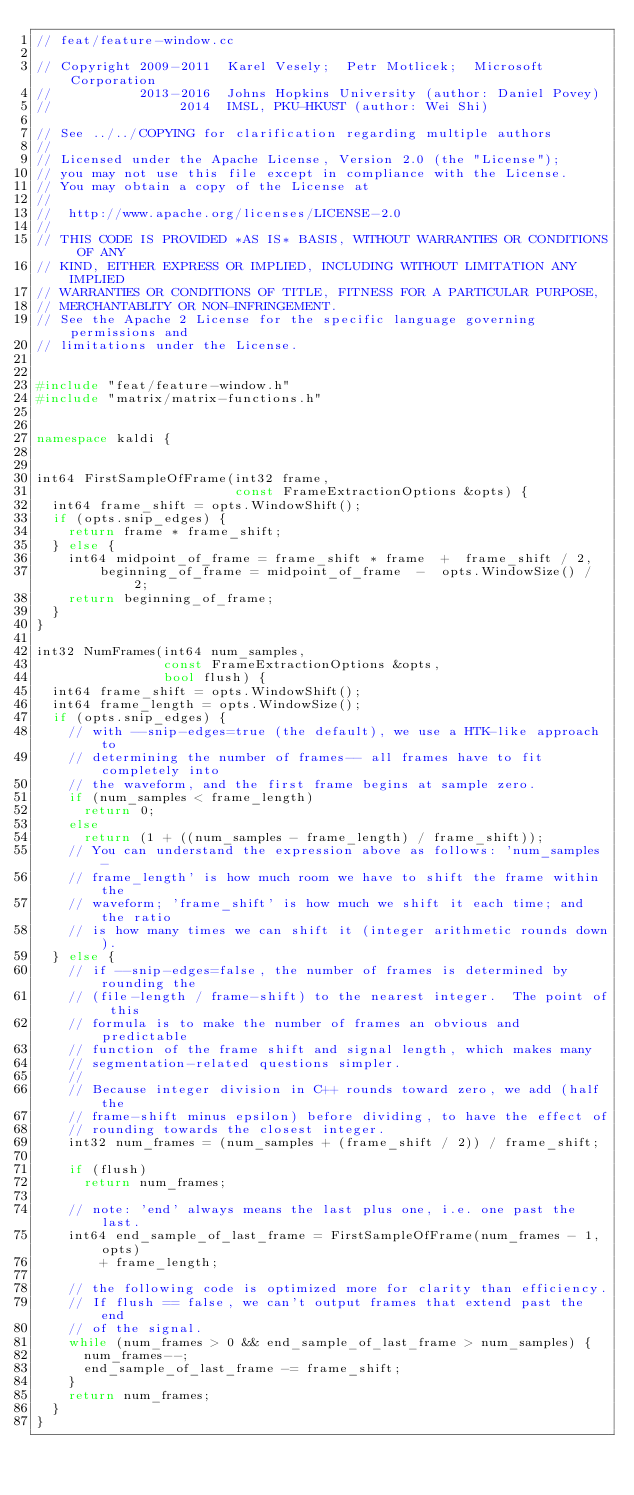Convert code to text. <code><loc_0><loc_0><loc_500><loc_500><_C++_>// feat/feature-window.cc

// Copyright 2009-2011  Karel Vesely;  Petr Motlicek;  Microsoft Corporation
//           2013-2016  Johns Hopkins University (author: Daniel Povey)
//                2014  IMSL, PKU-HKUST (author: Wei Shi)

// See ../../COPYING for clarification regarding multiple authors
//
// Licensed under the Apache License, Version 2.0 (the "License");
// you may not use this file except in compliance with the License.
// You may obtain a copy of the License at
//
//  http://www.apache.org/licenses/LICENSE-2.0
//
// THIS CODE IS PROVIDED *AS IS* BASIS, WITHOUT WARRANTIES OR CONDITIONS OF ANY
// KIND, EITHER EXPRESS OR IMPLIED, INCLUDING WITHOUT LIMITATION ANY IMPLIED
// WARRANTIES OR CONDITIONS OF TITLE, FITNESS FOR A PARTICULAR PURPOSE,
// MERCHANTABLITY OR NON-INFRINGEMENT.
// See the Apache 2 License for the specific language governing permissions and
// limitations under the License.


#include "feat/feature-window.h"
#include "matrix/matrix-functions.h"


namespace kaldi {


int64 FirstSampleOfFrame(int32 frame,
                         const FrameExtractionOptions &opts) {
  int64 frame_shift = opts.WindowShift();
  if (opts.snip_edges) {
    return frame * frame_shift;
  } else {
    int64 midpoint_of_frame = frame_shift * frame  +  frame_shift / 2,
        beginning_of_frame = midpoint_of_frame  -  opts.WindowSize() / 2;
    return beginning_of_frame;
  }
}

int32 NumFrames(int64 num_samples,
                const FrameExtractionOptions &opts,
                bool flush) {
  int64 frame_shift = opts.WindowShift();
  int64 frame_length = opts.WindowSize();
  if (opts.snip_edges) {
    // with --snip-edges=true (the default), we use a HTK-like approach to
    // determining the number of frames-- all frames have to fit completely into
    // the waveform, and the first frame begins at sample zero.
    if (num_samples < frame_length)
      return 0;
    else
      return (1 + ((num_samples - frame_length) / frame_shift));
    // You can understand the expression above as follows: 'num_samples -
    // frame_length' is how much room we have to shift the frame within the
    // waveform; 'frame_shift' is how much we shift it each time; and the ratio
    // is how many times we can shift it (integer arithmetic rounds down).
  } else {
    // if --snip-edges=false, the number of frames is determined by rounding the
    // (file-length / frame-shift) to the nearest integer.  The point of this
    // formula is to make the number of frames an obvious and predictable
    // function of the frame shift and signal length, which makes many
    // segmentation-related questions simpler.
    //
    // Because integer division in C++ rounds toward zero, we add (half the
    // frame-shift minus epsilon) before dividing, to have the effect of
    // rounding towards the closest integer.
    int32 num_frames = (num_samples + (frame_shift / 2)) / frame_shift;

    if (flush)
      return num_frames;

    // note: 'end' always means the last plus one, i.e. one past the last.
    int64 end_sample_of_last_frame = FirstSampleOfFrame(num_frames - 1, opts)
        + frame_length;

    // the following code is optimized more for clarity than efficiency.
    // If flush == false, we can't output frames that extend past the end
    // of the signal.
    while (num_frames > 0 && end_sample_of_last_frame > num_samples) {
      num_frames--;
      end_sample_of_last_frame -= frame_shift;
    }
    return num_frames;
  }
}

</code> 